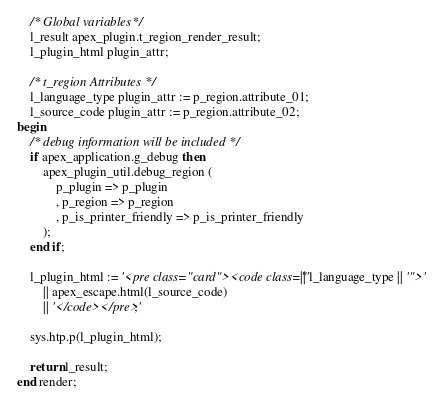Convert code to text. <code><loc_0><loc_0><loc_500><loc_500><_SQL_>
	/* Global variables */
	l_result apex_plugin.t_region_render_result;
	l_plugin_html plugin_attr;

	/* t_region Attributes */
	l_language_type plugin_attr := p_region.attribute_01;
	l_source_code plugin_attr := p_region.attribute_02;
begin
	/* debug information will be included */
	if apex_application.g_debug then
		apex_plugin_util.debug_region (
			p_plugin => p_plugin
			, p_region => p_region
			, p_is_printer_friendly => p_is_printer_friendly
		);
	end if;

	l_plugin_html := '<pre class="card"><code class="' || l_language_type || '">'
		|| apex_escape.html(l_source_code)
		|| '</code></pre>';

	sys.htp.p(l_plugin_html);

	return l_result;
end render;
</code> 